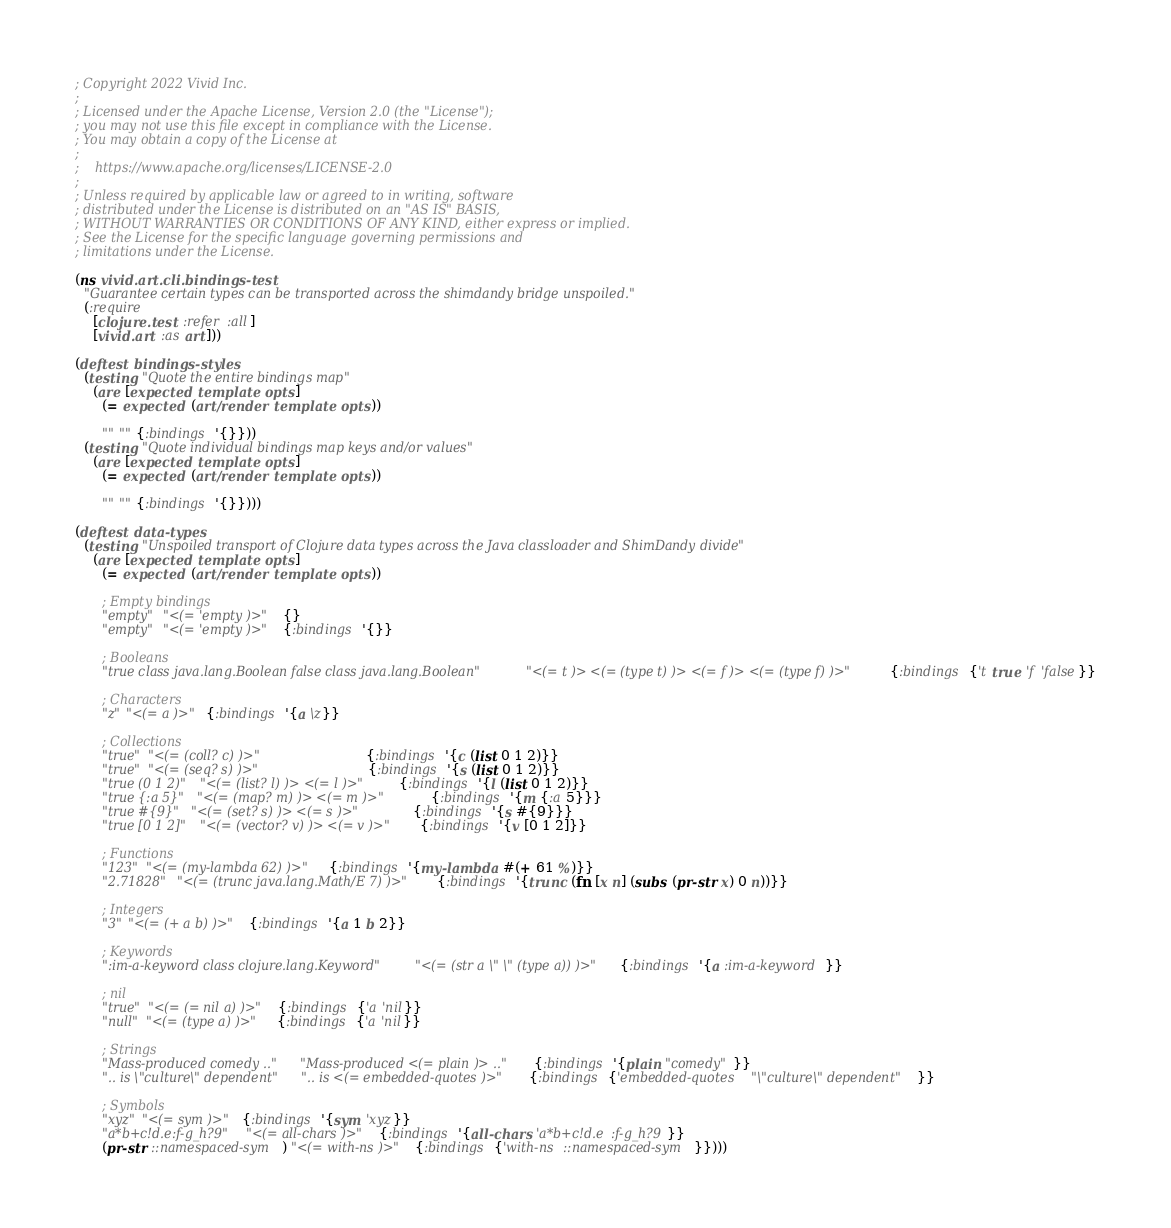<code> <loc_0><loc_0><loc_500><loc_500><_Clojure_>; Copyright 2022 Vivid Inc.
;
; Licensed under the Apache License, Version 2.0 (the "License");
; you may not use this file except in compliance with the License.
; You may obtain a copy of the License at
;
;    https://www.apache.org/licenses/LICENSE-2.0
;
; Unless required by applicable law or agreed to in writing, software
; distributed under the License is distributed on an "AS IS" BASIS,
; WITHOUT WARRANTIES OR CONDITIONS OF ANY KIND, either express or implied.
; See the License for the specific language governing permissions and
; limitations under the License.

(ns vivid.art.cli.bindings-test
  "Guarantee certain types can be transported across the shimdandy bridge unspoiled."
  (:require
    [clojure.test :refer :all]
    [vivid.art :as art]))

(deftest bindings-styles
  (testing "Quote the entire bindings map"
    (are [expected template opts]
      (= expected (art/render template opts))

      "" "" {:bindings '{}}))
  (testing "Quote individual bindings map keys and/or values"
    (are [expected template opts]
      (= expected (art/render template opts))

      "" "" {:bindings '{}})))

(deftest data-types
  (testing "Unspoiled transport of Clojure data types across the Java classloader and ShimDandy divide"
    (are [expected template opts]
      (= expected (art/render template opts))

      ; Empty bindings
      "empty" "<(= 'empty )>" {}
      "empty" "<(= 'empty )>" {:bindings '{}}

      ; Booleans
      "true class java.lang.Boolean false class java.lang.Boolean" "<(= t )> <(= (type t) )> <(= f )> <(= (type f) )>" {:bindings {'t true 'f 'false}}

      ; Characters
      "z" "<(= a )>" {:bindings '{a \z}}

      ; Collections
      "true" "<(= (coll? c) )>"                     {:bindings '{c (list 0 1 2)}}
      "true" "<(= (seq? s) )>"                      {:bindings '{s (list 0 1 2)}}
      "true (0 1 2)" "<(= (list? l) )> <(= l )>"    {:bindings '{l (list 0 1 2)}}
      "true {:a 5}" "<(= (map? m) )> <(= m )>"      {:bindings '{m {:a 5}}}
      "true #{9}" "<(= (set? s) )> <(= s )>"        {:bindings '{s #{9}}}
      "true [0 1 2]" "<(= (vector? v) )> <(= v )>"  {:bindings '{v [0 1 2]}}

      ; Functions
      "123" "<(= (my-lambda 62) )>" {:bindings '{my-lambda #(+ 61 %)}}
      "2.71828" "<(= (trunc java.lang.Math/E 7) )>" {:bindings '{trunc (fn [x n] (subs (pr-str x) 0 n))}}

      ; Integers
      "3" "<(= (+ a b) )>" {:bindings '{a 1 b 2}}

      ; Keywords
      ":im-a-keyword class clojure.lang.Keyword" "<(= (str a \" \" (type a)) )>" {:bindings '{a :im-a-keyword}}

      ; nil
      "true" "<(= (= nil a) )>" {:bindings {'a 'nil}}
      "null" "<(= (type a) )>"  {:bindings {'a 'nil}}

      ; Strings
      "Mass-produced comedy .." "Mass-produced <(= plain )> .." {:bindings '{plain "comedy"}}
      ".. is \"culture\" dependent" ".. is <(= embedded-quotes )>" {:bindings {'embedded-quotes "\"culture\" dependent"}}

      ; Symbols
      "xyz" "<(= sym )>" {:bindings '{sym 'xyz}}
      "a*b+c!d.e:f-g_h?9" "<(= all-chars )>" {:bindings '{all-chars 'a*b+c!d.e:f-g_h?9}}
      (pr-str ::namespaced-sym) "<(= with-ns )>" {:bindings {'with-ns ::namespaced-sym}})))
</code> 